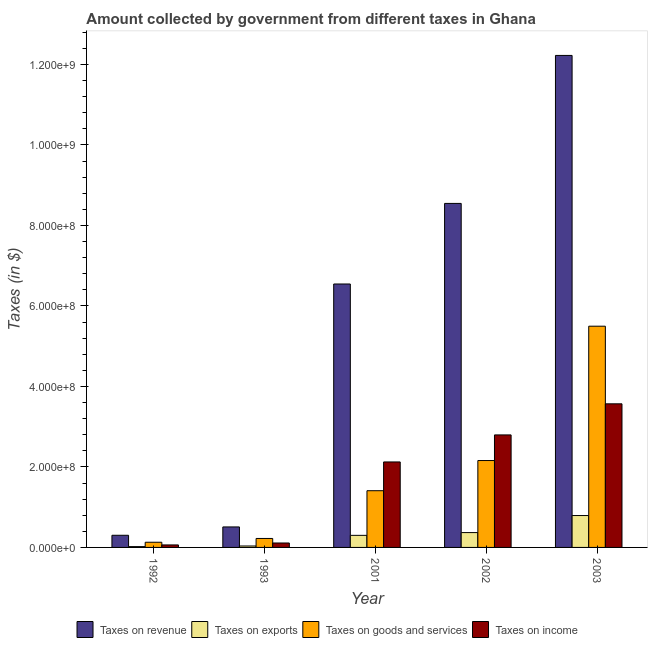How many different coloured bars are there?
Provide a succinct answer. 4. Are the number of bars per tick equal to the number of legend labels?
Give a very brief answer. Yes. Are the number of bars on each tick of the X-axis equal?
Make the answer very short. Yes. How many bars are there on the 1st tick from the left?
Keep it short and to the point. 4. How many bars are there on the 2nd tick from the right?
Your response must be concise. 4. What is the amount collected as tax on goods in 2001?
Make the answer very short. 1.41e+08. Across all years, what is the maximum amount collected as tax on revenue?
Keep it short and to the point. 1.22e+09. Across all years, what is the minimum amount collected as tax on goods?
Give a very brief answer. 1.29e+07. In which year was the amount collected as tax on revenue maximum?
Provide a succinct answer. 2003. What is the total amount collected as tax on goods in the graph?
Provide a succinct answer. 9.42e+08. What is the difference between the amount collected as tax on goods in 2001 and that in 2003?
Give a very brief answer. -4.09e+08. What is the difference between the amount collected as tax on income in 1992 and the amount collected as tax on exports in 2002?
Ensure brevity in your answer.  -2.73e+08. What is the average amount collected as tax on revenue per year?
Make the answer very short. 5.63e+08. In the year 1992, what is the difference between the amount collected as tax on exports and amount collected as tax on revenue?
Your answer should be compact. 0. In how many years, is the amount collected as tax on revenue greater than 520000000 $?
Offer a very short reply. 3. What is the ratio of the amount collected as tax on goods in 2002 to that in 2003?
Offer a terse response. 0.39. What is the difference between the highest and the second highest amount collected as tax on revenue?
Provide a succinct answer. 3.68e+08. What is the difference between the highest and the lowest amount collected as tax on income?
Your answer should be very brief. 3.51e+08. In how many years, is the amount collected as tax on revenue greater than the average amount collected as tax on revenue taken over all years?
Ensure brevity in your answer.  3. What does the 1st bar from the left in 1992 represents?
Your answer should be very brief. Taxes on revenue. What does the 2nd bar from the right in 1992 represents?
Make the answer very short. Taxes on goods and services. How many bars are there?
Keep it short and to the point. 20. Are all the bars in the graph horizontal?
Your answer should be compact. No. Does the graph contain grids?
Offer a terse response. No. Where does the legend appear in the graph?
Keep it short and to the point. Bottom center. How are the legend labels stacked?
Make the answer very short. Horizontal. What is the title of the graph?
Provide a short and direct response. Amount collected by government from different taxes in Ghana. What is the label or title of the X-axis?
Your answer should be very brief. Year. What is the label or title of the Y-axis?
Your answer should be compact. Taxes (in $). What is the Taxes (in $) in Taxes on revenue in 1992?
Provide a succinct answer. 3.02e+07. What is the Taxes (in $) of Taxes on exports in 1992?
Offer a very short reply. 2.04e+06. What is the Taxes (in $) of Taxes on goods and services in 1992?
Provide a succinct answer. 1.29e+07. What is the Taxes (in $) in Taxes on income in 1992?
Keep it short and to the point. 6.21e+06. What is the Taxes (in $) in Taxes on revenue in 1993?
Make the answer very short. 5.09e+07. What is the Taxes (in $) in Taxes on exports in 1993?
Your answer should be compact. 3.57e+06. What is the Taxes (in $) in Taxes on goods and services in 1993?
Give a very brief answer. 2.23e+07. What is the Taxes (in $) in Taxes on income in 1993?
Make the answer very short. 1.10e+07. What is the Taxes (in $) in Taxes on revenue in 2001?
Give a very brief answer. 6.55e+08. What is the Taxes (in $) in Taxes on exports in 2001?
Your answer should be compact. 3.00e+07. What is the Taxes (in $) in Taxes on goods and services in 2001?
Your answer should be very brief. 1.41e+08. What is the Taxes (in $) in Taxes on income in 2001?
Offer a terse response. 2.12e+08. What is the Taxes (in $) of Taxes on revenue in 2002?
Your answer should be compact. 8.55e+08. What is the Taxes (in $) of Taxes on exports in 2002?
Give a very brief answer. 3.69e+07. What is the Taxes (in $) in Taxes on goods and services in 2002?
Give a very brief answer. 2.16e+08. What is the Taxes (in $) of Taxes on income in 2002?
Offer a very short reply. 2.80e+08. What is the Taxes (in $) of Taxes on revenue in 2003?
Offer a very short reply. 1.22e+09. What is the Taxes (in $) of Taxes on exports in 2003?
Provide a succinct answer. 7.92e+07. What is the Taxes (in $) in Taxes on goods and services in 2003?
Your response must be concise. 5.50e+08. What is the Taxes (in $) of Taxes on income in 2003?
Give a very brief answer. 3.57e+08. Across all years, what is the maximum Taxes (in $) in Taxes on revenue?
Offer a terse response. 1.22e+09. Across all years, what is the maximum Taxes (in $) of Taxes on exports?
Make the answer very short. 7.92e+07. Across all years, what is the maximum Taxes (in $) of Taxes on goods and services?
Provide a short and direct response. 5.50e+08. Across all years, what is the maximum Taxes (in $) in Taxes on income?
Your answer should be compact. 3.57e+08. Across all years, what is the minimum Taxes (in $) in Taxes on revenue?
Your answer should be very brief. 3.02e+07. Across all years, what is the minimum Taxes (in $) of Taxes on exports?
Your response must be concise. 2.04e+06. Across all years, what is the minimum Taxes (in $) of Taxes on goods and services?
Keep it short and to the point. 1.29e+07. Across all years, what is the minimum Taxes (in $) in Taxes on income?
Ensure brevity in your answer.  6.21e+06. What is the total Taxes (in $) in Taxes on revenue in the graph?
Your answer should be compact. 2.81e+09. What is the total Taxes (in $) in Taxes on exports in the graph?
Offer a terse response. 1.52e+08. What is the total Taxes (in $) of Taxes on goods and services in the graph?
Provide a short and direct response. 9.42e+08. What is the total Taxes (in $) in Taxes on income in the graph?
Provide a succinct answer. 8.66e+08. What is the difference between the Taxes (in $) of Taxes on revenue in 1992 and that in 1993?
Ensure brevity in your answer.  -2.07e+07. What is the difference between the Taxes (in $) of Taxes on exports in 1992 and that in 1993?
Provide a succinct answer. -1.54e+06. What is the difference between the Taxes (in $) in Taxes on goods and services in 1992 and that in 1993?
Your answer should be very brief. -9.41e+06. What is the difference between the Taxes (in $) in Taxes on income in 1992 and that in 1993?
Offer a terse response. -4.82e+06. What is the difference between the Taxes (in $) of Taxes on revenue in 1992 and that in 2001?
Provide a short and direct response. -6.24e+08. What is the difference between the Taxes (in $) of Taxes on exports in 1992 and that in 2001?
Your answer should be very brief. -2.80e+07. What is the difference between the Taxes (in $) of Taxes on goods and services in 1992 and that in 2001?
Make the answer very short. -1.28e+08. What is the difference between the Taxes (in $) in Taxes on income in 1992 and that in 2001?
Your answer should be compact. -2.06e+08. What is the difference between the Taxes (in $) of Taxes on revenue in 1992 and that in 2002?
Your answer should be very brief. -8.25e+08. What is the difference between the Taxes (in $) in Taxes on exports in 1992 and that in 2002?
Offer a very short reply. -3.49e+07. What is the difference between the Taxes (in $) in Taxes on goods and services in 1992 and that in 2002?
Provide a succinct answer. -2.03e+08. What is the difference between the Taxes (in $) of Taxes on income in 1992 and that in 2002?
Keep it short and to the point. -2.73e+08. What is the difference between the Taxes (in $) in Taxes on revenue in 1992 and that in 2003?
Provide a short and direct response. -1.19e+09. What is the difference between the Taxes (in $) in Taxes on exports in 1992 and that in 2003?
Your answer should be very brief. -7.72e+07. What is the difference between the Taxes (in $) in Taxes on goods and services in 1992 and that in 2003?
Make the answer very short. -5.37e+08. What is the difference between the Taxes (in $) in Taxes on income in 1992 and that in 2003?
Your response must be concise. -3.51e+08. What is the difference between the Taxes (in $) of Taxes on revenue in 1993 and that in 2001?
Your response must be concise. -6.04e+08. What is the difference between the Taxes (in $) in Taxes on exports in 1993 and that in 2001?
Make the answer very short. -2.64e+07. What is the difference between the Taxes (in $) of Taxes on goods and services in 1993 and that in 2001?
Your response must be concise. -1.19e+08. What is the difference between the Taxes (in $) of Taxes on income in 1993 and that in 2001?
Keep it short and to the point. -2.01e+08. What is the difference between the Taxes (in $) in Taxes on revenue in 1993 and that in 2002?
Offer a terse response. -8.04e+08. What is the difference between the Taxes (in $) of Taxes on exports in 1993 and that in 2002?
Provide a succinct answer. -3.33e+07. What is the difference between the Taxes (in $) in Taxes on goods and services in 1993 and that in 2002?
Make the answer very short. -1.94e+08. What is the difference between the Taxes (in $) in Taxes on income in 1993 and that in 2002?
Provide a succinct answer. -2.69e+08. What is the difference between the Taxes (in $) in Taxes on revenue in 1993 and that in 2003?
Your response must be concise. -1.17e+09. What is the difference between the Taxes (in $) of Taxes on exports in 1993 and that in 2003?
Provide a succinct answer. -7.57e+07. What is the difference between the Taxes (in $) in Taxes on goods and services in 1993 and that in 2003?
Give a very brief answer. -5.27e+08. What is the difference between the Taxes (in $) in Taxes on income in 1993 and that in 2003?
Keep it short and to the point. -3.46e+08. What is the difference between the Taxes (in $) of Taxes on revenue in 2001 and that in 2002?
Your response must be concise. -2.00e+08. What is the difference between the Taxes (in $) of Taxes on exports in 2001 and that in 2002?
Give a very brief answer. -6.89e+06. What is the difference between the Taxes (in $) in Taxes on goods and services in 2001 and that in 2002?
Your response must be concise. -7.50e+07. What is the difference between the Taxes (in $) in Taxes on income in 2001 and that in 2002?
Give a very brief answer. -6.72e+07. What is the difference between the Taxes (in $) of Taxes on revenue in 2001 and that in 2003?
Your answer should be very brief. -5.68e+08. What is the difference between the Taxes (in $) in Taxes on exports in 2001 and that in 2003?
Make the answer very short. -4.92e+07. What is the difference between the Taxes (in $) of Taxes on goods and services in 2001 and that in 2003?
Keep it short and to the point. -4.09e+08. What is the difference between the Taxes (in $) in Taxes on income in 2001 and that in 2003?
Your answer should be very brief. -1.44e+08. What is the difference between the Taxes (in $) in Taxes on revenue in 2002 and that in 2003?
Your answer should be compact. -3.68e+08. What is the difference between the Taxes (in $) in Taxes on exports in 2002 and that in 2003?
Offer a very short reply. -4.24e+07. What is the difference between the Taxes (in $) of Taxes on goods and services in 2002 and that in 2003?
Offer a very short reply. -3.34e+08. What is the difference between the Taxes (in $) in Taxes on income in 2002 and that in 2003?
Offer a very short reply. -7.73e+07. What is the difference between the Taxes (in $) of Taxes on revenue in 1992 and the Taxes (in $) of Taxes on exports in 1993?
Your answer should be very brief. 2.66e+07. What is the difference between the Taxes (in $) of Taxes on revenue in 1992 and the Taxes (in $) of Taxes on goods and services in 1993?
Your answer should be compact. 7.90e+06. What is the difference between the Taxes (in $) in Taxes on revenue in 1992 and the Taxes (in $) in Taxes on income in 1993?
Make the answer very short. 1.92e+07. What is the difference between the Taxes (in $) in Taxes on exports in 1992 and the Taxes (in $) in Taxes on goods and services in 1993?
Offer a very short reply. -2.03e+07. What is the difference between the Taxes (in $) of Taxes on exports in 1992 and the Taxes (in $) of Taxes on income in 1993?
Ensure brevity in your answer.  -8.99e+06. What is the difference between the Taxes (in $) of Taxes on goods and services in 1992 and the Taxes (in $) of Taxes on income in 1993?
Your answer should be very brief. 1.85e+06. What is the difference between the Taxes (in $) in Taxes on revenue in 1992 and the Taxes (in $) in Taxes on exports in 2001?
Keep it short and to the point. 1.87e+05. What is the difference between the Taxes (in $) of Taxes on revenue in 1992 and the Taxes (in $) of Taxes on goods and services in 2001?
Your answer should be very brief. -1.11e+08. What is the difference between the Taxes (in $) in Taxes on revenue in 1992 and the Taxes (in $) in Taxes on income in 2001?
Keep it short and to the point. -1.82e+08. What is the difference between the Taxes (in $) of Taxes on exports in 1992 and the Taxes (in $) of Taxes on goods and services in 2001?
Give a very brief answer. -1.39e+08. What is the difference between the Taxes (in $) in Taxes on exports in 1992 and the Taxes (in $) in Taxes on income in 2001?
Keep it short and to the point. -2.10e+08. What is the difference between the Taxes (in $) of Taxes on goods and services in 1992 and the Taxes (in $) of Taxes on income in 2001?
Keep it short and to the point. -1.99e+08. What is the difference between the Taxes (in $) of Taxes on revenue in 1992 and the Taxes (in $) of Taxes on exports in 2002?
Ensure brevity in your answer.  -6.70e+06. What is the difference between the Taxes (in $) in Taxes on revenue in 1992 and the Taxes (in $) in Taxes on goods and services in 2002?
Your answer should be very brief. -1.86e+08. What is the difference between the Taxes (in $) of Taxes on revenue in 1992 and the Taxes (in $) of Taxes on income in 2002?
Ensure brevity in your answer.  -2.49e+08. What is the difference between the Taxes (in $) in Taxes on exports in 1992 and the Taxes (in $) in Taxes on goods and services in 2002?
Your response must be concise. -2.14e+08. What is the difference between the Taxes (in $) in Taxes on exports in 1992 and the Taxes (in $) in Taxes on income in 2002?
Make the answer very short. -2.78e+08. What is the difference between the Taxes (in $) of Taxes on goods and services in 1992 and the Taxes (in $) of Taxes on income in 2002?
Your answer should be compact. -2.67e+08. What is the difference between the Taxes (in $) of Taxes on revenue in 1992 and the Taxes (in $) of Taxes on exports in 2003?
Make the answer very short. -4.91e+07. What is the difference between the Taxes (in $) in Taxes on revenue in 1992 and the Taxes (in $) in Taxes on goods and services in 2003?
Make the answer very short. -5.19e+08. What is the difference between the Taxes (in $) of Taxes on revenue in 1992 and the Taxes (in $) of Taxes on income in 2003?
Offer a terse response. -3.27e+08. What is the difference between the Taxes (in $) in Taxes on exports in 1992 and the Taxes (in $) in Taxes on goods and services in 2003?
Your response must be concise. -5.48e+08. What is the difference between the Taxes (in $) in Taxes on exports in 1992 and the Taxes (in $) in Taxes on income in 2003?
Ensure brevity in your answer.  -3.55e+08. What is the difference between the Taxes (in $) of Taxes on goods and services in 1992 and the Taxes (in $) of Taxes on income in 2003?
Keep it short and to the point. -3.44e+08. What is the difference between the Taxes (in $) of Taxes on revenue in 1993 and the Taxes (in $) of Taxes on exports in 2001?
Your answer should be very brief. 2.09e+07. What is the difference between the Taxes (in $) of Taxes on revenue in 1993 and the Taxes (in $) of Taxes on goods and services in 2001?
Provide a short and direct response. -9.00e+07. What is the difference between the Taxes (in $) in Taxes on revenue in 1993 and the Taxes (in $) in Taxes on income in 2001?
Your response must be concise. -1.61e+08. What is the difference between the Taxes (in $) of Taxes on exports in 1993 and the Taxes (in $) of Taxes on goods and services in 2001?
Give a very brief answer. -1.37e+08. What is the difference between the Taxes (in $) of Taxes on exports in 1993 and the Taxes (in $) of Taxes on income in 2001?
Keep it short and to the point. -2.09e+08. What is the difference between the Taxes (in $) in Taxes on goods and services in 1993 and the Taxes (in $) in Taxes on income in 2001?
Make the answer very short. -1.90e+08. What is the difference between the Taxes (in $) of Taxes on revenue in 1993 and the Taxes (in $) of Taxes on exports in 2002?
Provide a succinct answer. 1.40e+07. What is the difference between the Taxes (in $) in Taxes on revenue in 1993 and the Taxes (in $) in Taxes on goods and services in 2002?
Your answer should be very brief. -1.65e+08. What is the difference between the Taxes (in $) in Taxes on revenue in 1993 and the Taxes (in $) in Taxes on income in 2002?
Give a very brief answer. -2.29e+08. What is the difference between the Taxes (in $) in Taxes on exports in 1993 and the Taxes (in $) in Taxes on goods and services in 2002?
Your answer should be compact. -2.12e+08. What is the difference between the Taxes (in $) of Taxes on exports in 1993 and the Taxes (in $) of Taxes on income in 2002?
Make the answer very short. -2.76e+08. What is the difference between the Taxes (in $) in Taxes on goods and services in 1993 and the Taxes (in $) in Taxes on income in 2002?
Provide a succinct answer. -2.57e+08. What is the difference between the Taxes (in $) of Taxes on revenue in 1993 and the Taxes (in $) of Taxes on exports in 2003?
Provide a short and direct response. -2.83e+07. What is the difference between the Taxes (in $) in Taxes on revenue in 1993 and the Taxes (in $) in Taxes on goods and services in 2003?
Ensure brevity in your answer.  -4.99e+08. What is the difference between the Taxes (in $) in Taxes on revenue in 1993 and the Taxes (in $) in Taxes on income in 2003?
Keep it short and to the point. -3.06e+08. What is the difference between the Taxes (in $) of Taxes on exports in 1993 and the Taxes (in $) of Taxes on goods and services in 2003?
Provide a short and direct response. -5.46e+08. What is the difference between the Taxes (in $) of Taxes on exports in 1993 and the Taxes (in $) of Taxes on income in 2003?
Your response must be concise. -3.53e+08. What is the difference between the Taxes (in $) in Taxes on goods and services in 1993 and the Taxes (in $) in Taxes on income in 2003?
Your response must be concise. -3.35e+08. What is the difference between the Taxes (in $) in Taxes on revenue in 2001 and the Taxes (in $) in Taxes on exports in 2002?
Your answer should be very brief. 6.18e+08. What is the difference between the Taxes (in $) of Taxes on revenue in 2001 and the Taxes (in $) of Taxes on goods and services in 2002?
Your response must be concise. 4.39e+08. What is the difference between the Taxes (in $) of Taxes on revenue in 2001 and the Taxes (in $) of Taxes on income in 2002?
Give a very brief answer. 3.75e+08. What is the difference between the Taxes (in $) of Taxes on exports in 2001 and the Taxes (in $) of Taxes on goods and services in 2002?
Ensure brevity in your answer.  -1.86e+08. What is the difference between the Taxes (in $) of Taxes on exports in 2001 and the Taxes (in $) of Taxes on income in 2002?
Your answer should be compact. -2.50e+08. What is the difference between the Taxes (in $) of Taxes on goods and services in 2001 and the Taxes (in $) of Taxes on income in 2002?
Your answer should be compact. -1.39e+08. What is the difference between the Taxes (in $) in Taxes on revenue in 2001 and the Taxes (in $) in Taxes on exports in 2003?
Provide a succinct answer. 5.75e+08. What is the difference between the Taxes (in $) of Taxes on revenue in 2001 and the Taxes (in $) of Taxes on goods and services in 2003?
Your answer should be very brief. 1.05e+08. What is the difference between the Taxes (in $) of Taxes on revenue in 2001 and the Taxes (in $) of Taxes on income in 2003?
Offer a terse response. 2.98e+08. What is the difference between the Taxes (in $) of Taxes on exports in 2001 and the Taxes (in $) of Taxes on goods and services in 2003?
Provide a succinct answer. -5.20e+08. What is the difference between the Taxes (in $) in Taxes on exports in 2001 and the Taxes (in $) in Taxes on income in 2003?
Keep it short and to the point. -3.27e+08. What is the difference between the Taxes (in $) in Taxes on goods and services in 2001 and the Taxes (in $) in Taxes on income in 2003?
Make the answer very short. -2.16e+08. What is the difference between the Taxes (in $) in Taxes on revenue in 2002 and the Taxes (in $) in Taxes on exports in 2003?
Offer a terse response. 7.76e+08. What is the difference between the Taxes (in $) of Taxes on revenue in 2002 and the Taxes (in $) of Taxes on goods and services in 2003?
Offer a very short reply. 3.05e+08. What is the difference between the Taxes (in $) in Taxes on revenue in 2002 and the Taxes (in $) in Taxes on income in 2003?
Provide a succinct answer. 4.98e+08. What is the difference between the Taxes (in $) in Taxes on exports in 2002 and the Taxes (in $) in Taxes on goods and services in 2003?
Ensure brevity in your answer.  -5.13e+08. What is the difference between the Taxes (in $) of Taxes on exports in 2002 and the Taxes (in $) of Taxes on income in 2003?
Your answer should be compact. -3.20e+08. What is the difference between the Taxes (in $) of Taxes on goods and services in 2002 and the Taxes (in $) of Taxes on income in 2003?
Your response must be concise. -1.41e+08. What is the average Taxes (in $) of Taxes on revenue per year?
Offer a terse response. 5.63e+08. What is the average Taxes (in $) of Taxes on exports per year?
Make the answer very short. 3.03e+07. What is the average Taxes (in $) in Taxes on goods and services per year?
Your response must be concise. 1.88e+08. What is the average Taxes (in $) in Taxes on income per year?
Offer a very short reply. 1.73e+08. In the year 1992, what is the difference between the Taxes (in $) in Taxes on revenue and Taxes (in $) in Taxes on exports?
Provide a short and direct response. 2.81e+07. In the year 1992, what is the difference between the Taxes (in $) of Taxes on revenue and Taxes (in $) of Taxes on goods and services?
Your response must be concise. 1.73e+07. In the year 1992, what is the difference between the Taxes (in $) in Taxes on revenue and Taxes (in $) in Taxes on income?
Keep it short and to the point. 2.40e+07. In the year 1992, what is the difference between the Taxes (in $) in Taxes on exports and Taxes (in $) in Taxes on goods and services?
Provide a short and direct response. -1.08e+07. In the year 1992, what is the difference between the Taxes (in $) in Taxes on exports and Taxes (in $) in Taxes on income?
Your answer should be very brief. -4.17e+06. In the year 1992, what is the difference between the Taxes (in $) of Taxes on goods and services and Taxes (in $) of Taxes on income?
Ensure brevity in your answer.  6.67e+06. In the year 1993, what is the difference between the Taxes (in $) in Taxes on revenue and Taxes (in $) in Taxes on exports?
Your answer should be very brief. 4.73e+07. In the year 1993, what is the difference between the Taxes (in $) in Taxes on revenue and Taxes (in $) in Taxes on goods and services?
Keep it short and to the point. 2.86e+07. In the year 1993, what is the difference between the Taxes (in $) in Taxes on revenue and Taxes (in $) in Taxes on income?
Keep it short and to the point. 3.99e+07. In the year 1993, what is the difference between the Taxes (in $) in Taxes on exports and Taxes (in $) in Taxes on goods and services?
Ensure brevity in your answer.  -1.87e+07. In the year 1993, what is the difference between the Taxes (in $) of Taxes on exports and Taxes (in $) of Taxes on income?
Provide a short and direct response. -7.46e+06. In the year 1993, what is the difference between the Taxes (in $) of Taxes on goods and services and Taxes (in $) of Taxes on income?
Your answer should be very brief. 1.13e+07. In the year 2001, what is the difference between the Taxes (in $) in Taxes on revenue and Taxes (in $) in Taxes on exports?
Provide a short and direct response. 6.25e+08. In the year 2001, what is the difference between the Taxes (in $) in Taxes on revenue and Taxes (in $) in Taxes on goods and services?
Keep it short and to the point. 5.14e+08. In the year 2001, what is the difference between the Taxes (in $) in Taxes on revenue and Taxes (in $) in Taxes on income?
Provide a succinct answer. 4.42e+08. In the year 2001, what is the difference between the Taxes (in $) in Taxes on exports and Taxes (in $) in Taxes on goods and services?
Provide a succinct answer. -1.11e+08. In the year 2001, what is the difference between the Taxes (in $) in Taxes on exports and Taxes (in $) in Taxes on income?
Your answer should be compact. -1.82e+08. In the year 2001, what is the difference between the Taxes (in $) in Taxes on goods and services and Taxes (in $) in Taxes on income?
Make the answer very short. -7.14e+07. In the year 2002, what is the difference between the Taxes (in $) of Taxes on revenue and Taxes (in $) of Taxes on exports?
Your answer should be compact. 8.18e+08. In the year 2002, what is the difference between the Taxes (in $) in Taxes on revenue and Taxes (in $) in Taxes on goods and services?
Offer a terse response. 6.39e+08. In the year 2002, what is the difference between the Taxes (in $) of Taxes on revenue and Taxes (in $) of Taxes on income?
Offer a very short reply. 5.75e+08. In the year 2002, what is the difference between the Taxes (in $) in Taxes on exports and Taxes (in $) in Taxes on goods and services?
Provide a short and direct response. -1.79e+08. In the year 2002, what is the difference between the Taxes (in $) in Taxes on exports and Taxes (in $) in Taxes on income?
Your response must be concise. -2.43e+08. In the year 2002, what is the difference between the Taxes (in $) of Taxes on goods and services and Taxes (in $) of Taxes on income?
Your response must be concise. -6.37e+07. In the year 2003, what is the difference between the Taxes (in $) of Taxes on revenue and Taxes (in $) of Taxes on exports?
Provide a succinct answer. 1.14e+09. In the year 2003, what is the difference between the Taxes (in $) of Taxes on revenue and Taxes (in $) of Taxes on goods and services?
Keep it short and to the point. 6.73e+08. In the year 2003, what is the difference between the Taxes (in $) in Taxes on revenue and Taxes (in $) in Taxes on income?
Your answer should be compact. 8.66e+08. In the year 2003, what is the difference between the Taxes (in $) in Taxes on exports and Taxes (in $) in Taxes on goods and services?
Offer a terse response. -4.70e+08. In the year 2003, what is the difference between the Taxes (in $) in Taxes on exports and Taxes (in $) in Taxes on income?
Ensure brevity in your answer.  -2.78e+08. In the year 2003, what is the difference between the Taxes (in $) of Taxes on goods and services and Taxes (in $) of Taxes on income?
Make the answer very short. 1.93e+08. What is the ratio of the Taxes (in $) of Taxes on revenue in 1992 to that in 1993?
Make the answer very short. 0.59. What is the ratio of the Taxes (in $) of Taxes on exports in 1992 to that in 1993?
Give a very brief answer. 0.57. What is the ratio of the Taxes (in $) of Taxes on goods and services in 1992 to that in 1993?
Offer a very short reply. 0.58. What is the ratio of the Taxes (in $) in Taxes on income in 1992 to that in 1993?
Your response must be concise. 0.56. What is the ratio of the Taxes (in $) in Taxes on revenue in 1992 to that in 2001?
Offer a very short reply. 0.05. What is the ratio of the Taxes (in $) in Taxes on exports in 1992 to that in 2001?
Make the answer very short. 0.07. What is the ratio of the Taxes (in $) of Taxes on goods and services in 1992 to that in 2001?
Provide a short and direct response. 0.09. What is the ratio of the Taxes (in $) in Taxes on income in 1992 to that in 2001?
Your response must be concise. 0.03. What is the ratio of the Taxes (in $) in Taxes on revenue in 1992 to that in 2002?
Offer a terse response. 0.04. What is the ratio of the Taxes (in $) in Taxes on exports in 1992 to that in 2002?
Ensure brevity in your answer.  0.06. What is the ratio of the Taxes (in $) of Taxes on goods and services in 1992 to that in 2002?
Offer a very short reply. 0.06. What is the ratio of the Taxes (in $) in Taxes on income in 1992 to that in 2002?
Provide a succinct answer. 0.02. What is the ratio of the Taxes (in $) of Taxes on revenue in 1992 to that in 2003?
Give a very brief answer. 0.02. What is the ratio of the Taxes (in $) of Taxes on exports in 1992 to that in 2003?
Provide a short and direct response. 0.03. What is the ratio of the Taxes (in $) of Taxes on goods and services in 1992 to that in 2003?
Offer a very short reply. 0.02. What is the ratio of the Taxes (in $) of Taxes on income in 1992 to that in 2003?
Provide a short and direct response. 0.02. What is the ratio of the Taxes (in $) in Taxes on revenue in 1993 to that in 2001?
Your response must be concise. 0.08. What is the ratio of the Taxes (in $) of Taxes on exports in 1993 to that in 2001?
Your response must be concise. 0.12. What is the ratio of the Taxes (in $) in Taxes on goods and services in 1993 to that in 2001?
Give a very brief answer. 0.16. What is the ratio of the Taxes (in $) of Taxes on income in 1993 to that in 2001?
Your answer should be compact. 0.05. What is the ratio of the Taxes (in $) of Taxes on revenue in 1993 to that in 2002?
Your answer should be very brief. 0.06. What is the ratio of the Taxes (in $) in Taxes on exports in 1993 to that in 2002?
Your answer should be compact. 0.1. What is the ratio of the Taxes (in $) in Taxes on goods and services in 1993 to that in 2002?
Your response must be concise. 0.1. What is the ratio of the Taxes (in $) of Taxes on income in 1993 to that in 2002?
Provide a short and direct response. 0.04. What is the ratio of the Taxes (in $) of Taxes on revenue in 1993 to that in 2003?
Your response must be concise. 0.04. What is the ratio of the Taxes (in $) in Taxes on exports in 1993 to that in 2003?
Your response must be concise. 0.05. What is the ratio of the Taxes (in $) of Taxes on goods and services in 1993 to that in 2003?
Provide a succinct answer. 0.04. What is the ratio of the Taxes (in $) of Taxes on income in 1993 to that in 2003?
Provide a short and direct response. 0.03. What is the ratio of the Taxes (in $) of Taxes on revenue in 2001 to that in 2002?
Ensure brevity in your answer.  0.77. What is the ratio of the Taxes (in $) in Taxes on exports in 2001 to that in 2002?
Keep it short and to the point. 0.81. What is the ratio of the Taxes (in $) of Taxes on goods and services in 2001 to that in 2002?
Give a very brief answer. 0.65. What is the ratio of the Taxes (in $) in Taxes on income in 2001 to that in 2002?
Your answer should be compact. 0.76. What is the ratio of the Taxes (in $) of Taxes on revenue in 2001 to that in 2003?
Offer a very short reply. 0.54. What is the ratio of the Taxes (in $) in Taxes on exports in 2001 to that in 2003?
Ensure brevity in your answer.  0.38. What is the ratio of the Taxes (in $) in Taxes on goods and services in 2001 to that in 2003?
Make the answer very short. 0.26. What is the ratio of the Taxes (in $) in Taxes on income in 2001 to that in 2003?
Your response must be concise. 0.6. What is the ratio of the Taxes (in $) in Taxes on revenue in 2002 to that in 2003?
Provide a short and direct response. 0.7. What is the ratio of the Taxes (in $) in Taxes on exports in 2002 to that in 2003?
Provide a succinct answer. 0.47. What is the ratio of the Taxes (in $) in Taxes on goods and services in 2002 to that in 2003?
Keep it short and to the point. 0.39. What is the ratio of the Taxes (in $) in Taxes on income in 2002 to that in 2003?
Your answer should be compact. 0.78. What is the difference between the highest and the second highest Taxes (in $) of Taxes on revenue?
Your response must be concise. 3.68e+08. What is the difference between the highest and the second highest Taxes (in $) of Taxes on exports?
Your answer should be very brief. 4.24e+07. What is the difference between the highest and the second highest Taxes (in $) of Taxes on goods and services?
Provide a succinct answer. 3.34e+08. What is the difference between the highest and the second highest Taxes (in $) in Taxes on income?
Provide a short and direct response. 7.73e+07. What is the difference between the highest and the lowest Taxes (in $) of Taxes on revenue?
Your response must be concise. 1.19e+09. What is the difference between the highest and the lowest Taxes (in $) of Taxes on exports?
Your response must be concise. 7.72e+07. What is the difference between the highest and the lowest Taxes (in $) in Taxes on goods and services?
Make the answer very short. 5.37e+08. What is the difference between the highest and the lowest Taxes (in $) of Taxes on income?
Your answer should be very brief. 3.51e+08. 